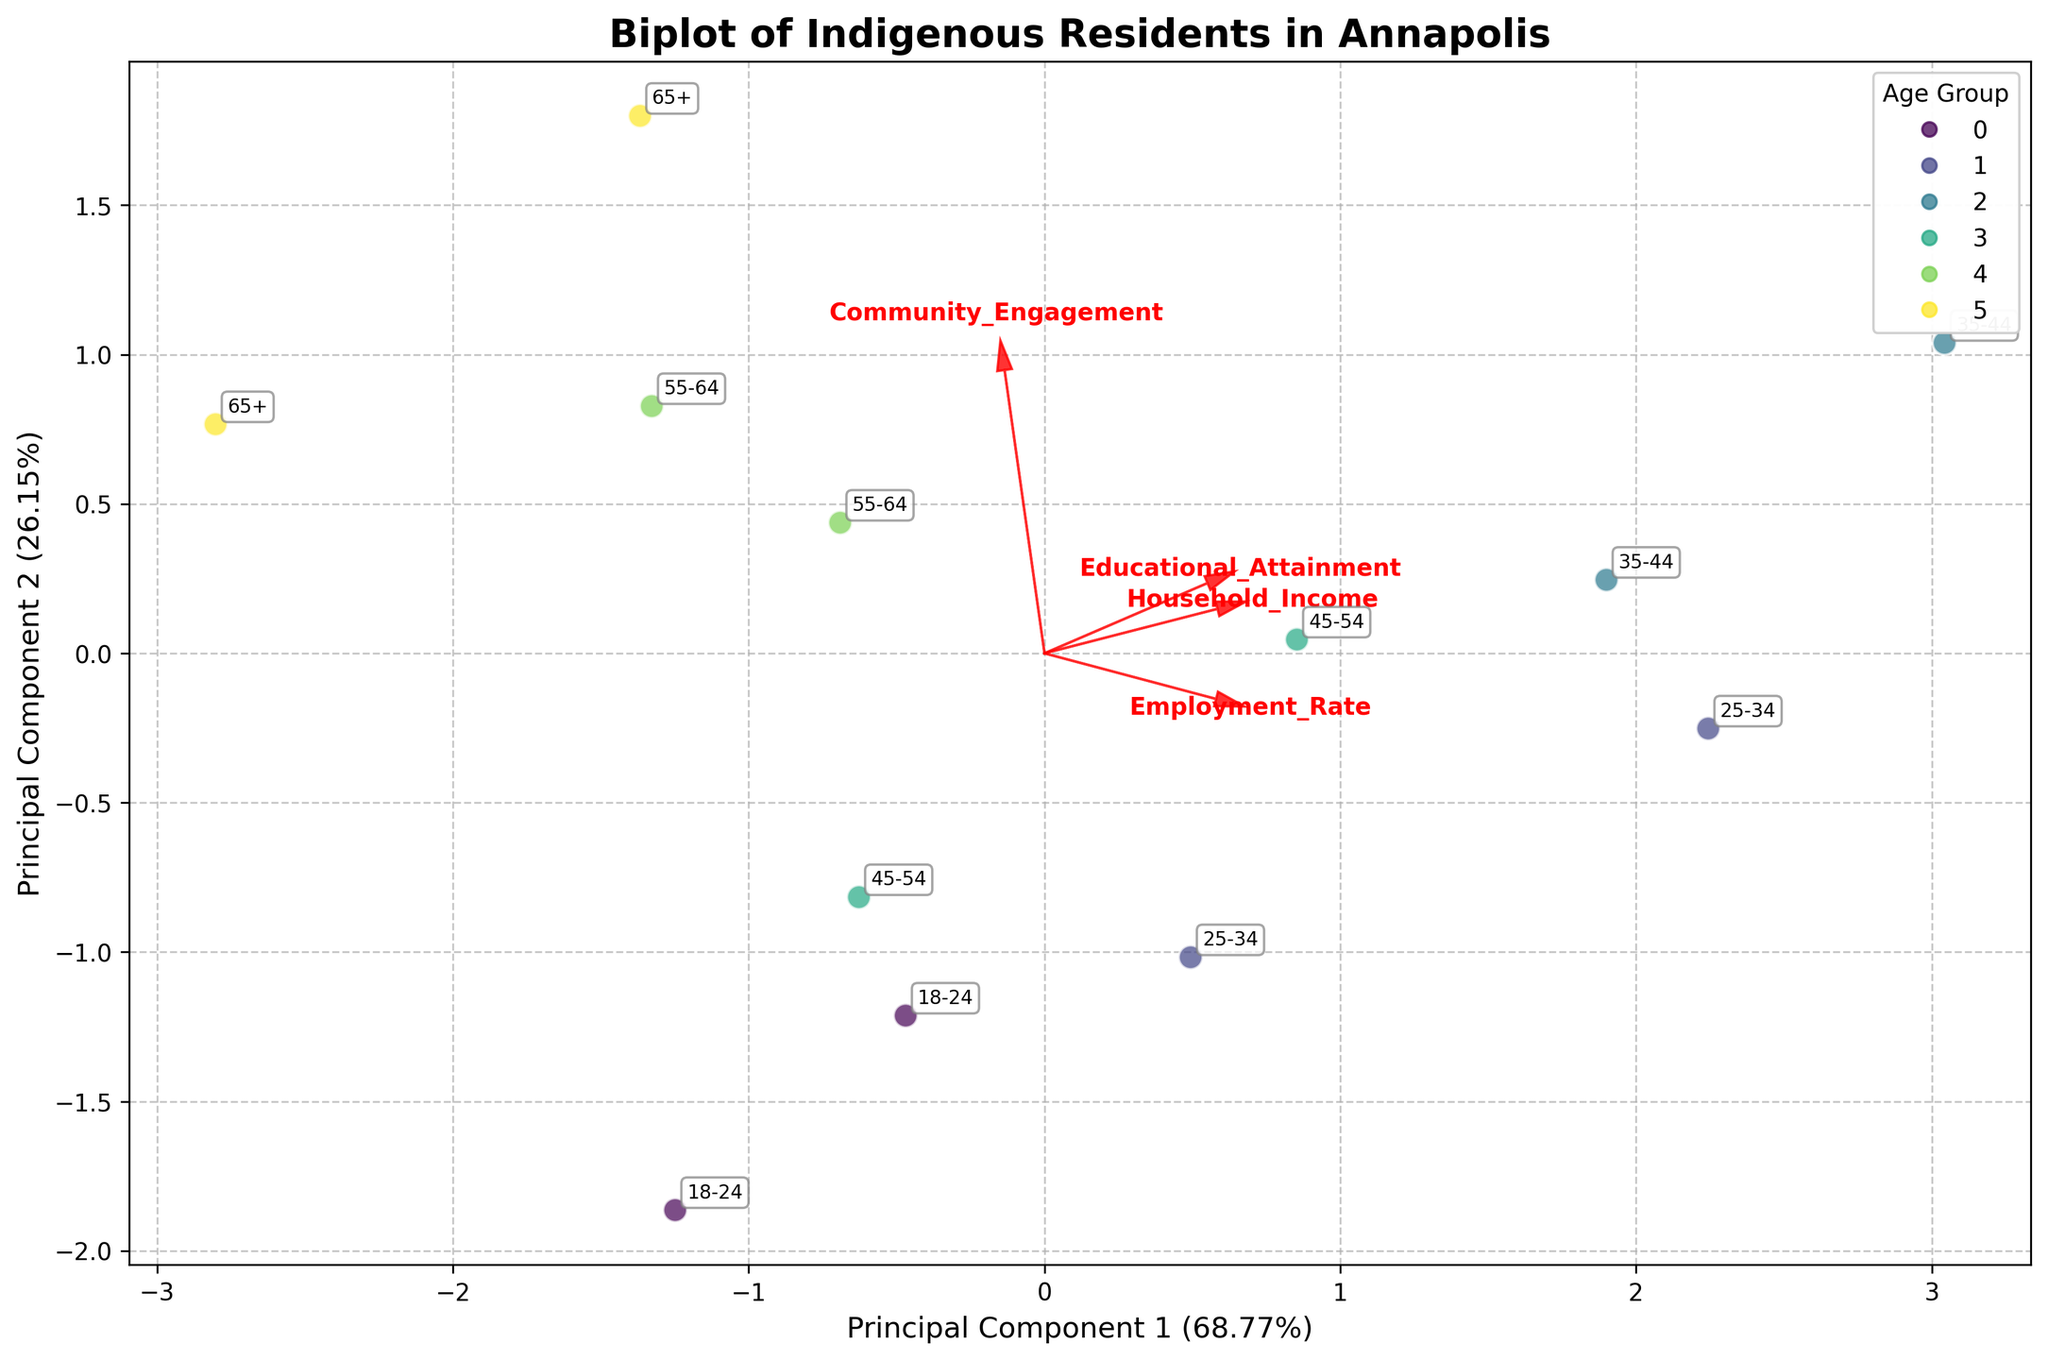How many data points are plotted in the figure? The figure represents the analysis of educational attainment and employment rates among Indigenous residents in Annapolis across various age brackets. There are 6 age groups each with 2 entries, meaning there are 12 data points plotted.
Answer: 12 What age group has the highest employment rate and what is that rate? According to the biplot, the 25-34 age group with a Bachelor’s Degree has the highest employment rate.
Answer: 80 Which principal component explains the majority of the variance, and what percentage does it explain? The biplot shows the variance explained by the two principal components on the axes. Principal Component 1 explains more variance than Principal Component 2; it explains around 60% of the variance.
Answer: Principal Component 1, 60% Which age group is associated with the lowest household income? By locating each age group point, the 65+ age group with less than a high school diploma is associated with the lowest household income.
Answer: 65+ How are educational attainment and employment rate related to Principal Component 2? Principal Component 2 shows how much each original feature contributes to it. From the direction of the feature vectors, high educational attainment and employment rate have a positive relationship with Principal Component 2.
Answer: Positively related Which feature contributes the most to Principal Component 1? The feature arrows on the biplot indicate the contribution. For Principal Component 1, educational attainment contributes the most as it points farthest along the PC1 axis.
Answer: Educational Attainment Comparing the 25-34 and 45-54 age groups, which has a higher community engagement score? By comparing their positions and checking the annotations for community engagement, the 65+ age group has a higher community engagement score.
Answer: 65+ Which two age groups have the closest employment rates? Checking the proximity of points on the employment rate dimension, the 18-24 and 65+ age groups with some college/less than high school have similar rates around the 50% mark.
Answer: 18-24 and 55-64 with some college What percentage of the variance is explained by Principal Component 2? The variance explained by Principal Component 2 is shown on its axis. Principal Component 2 accounts for approximately 25% of the variance.
Answer: 25% How are Household Income and Community Engagement related to the principal components? From the direction and length of the vectors, Household Income is positively related to Principal Component 1, while Community Engagement is positively related to Principal Component 2.
Answer: Household Income: Positive with PC1, Community Engagement: Positive with PC2 